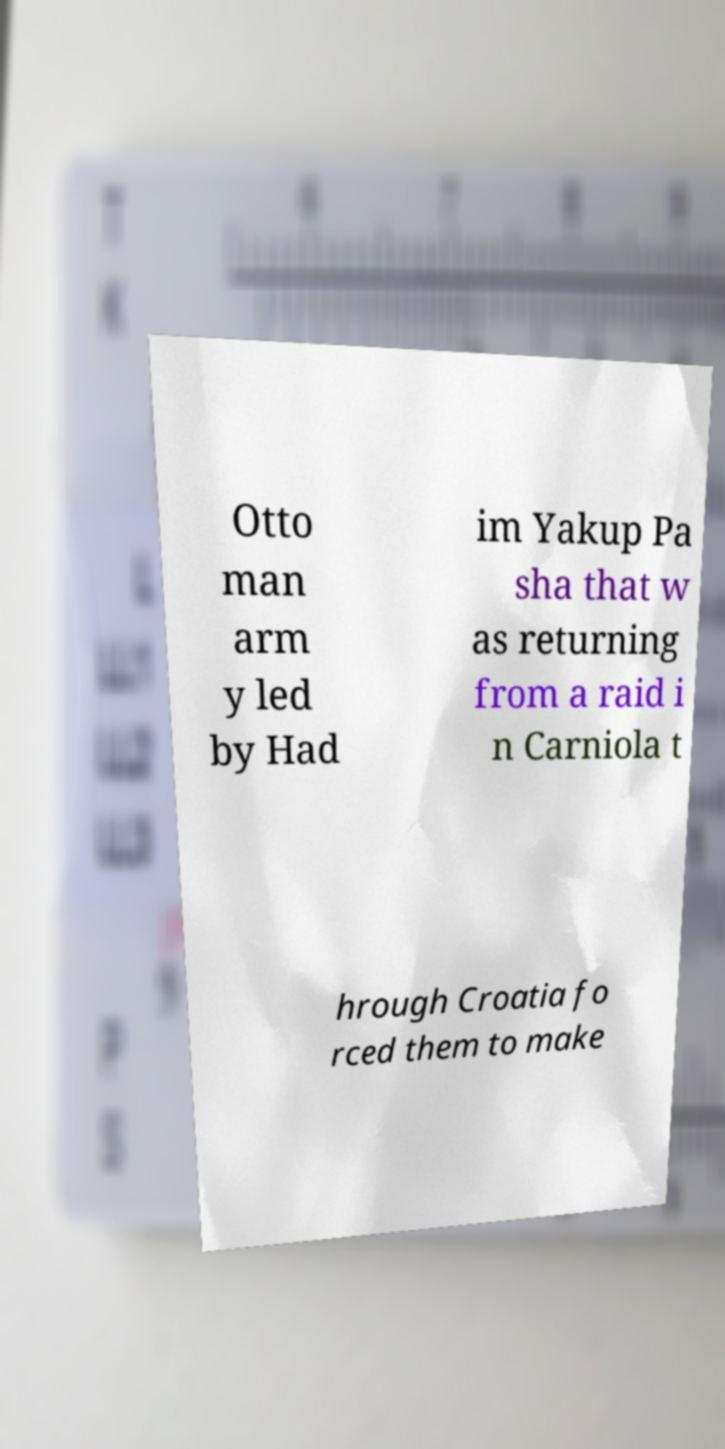Please identify and transcribe the text found in this image. Otto man arm y led by Had im Yakup Pa sha that w as returning from a raid i n Carniola t hrough Croatia fo rced them to make 